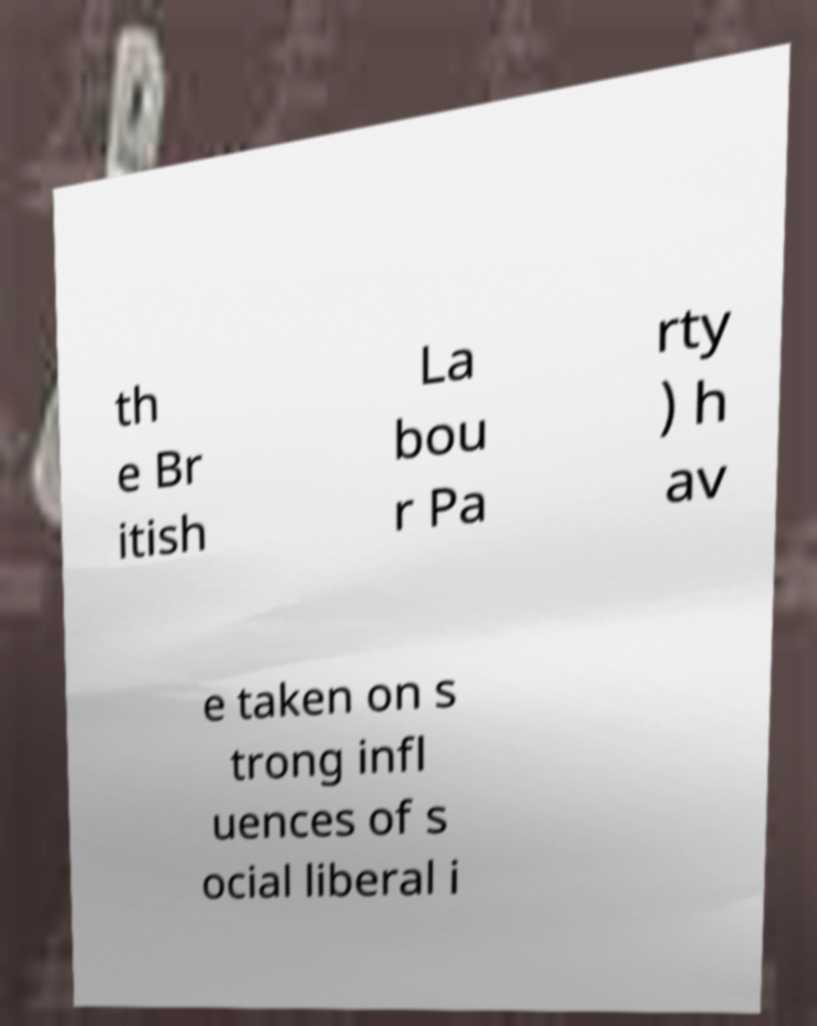I need the written content from this picture converted into text. Can you do that? th e Br itish La bou r Pa rty ) h av e taken on s trong infl uences of s ocial liberal i 